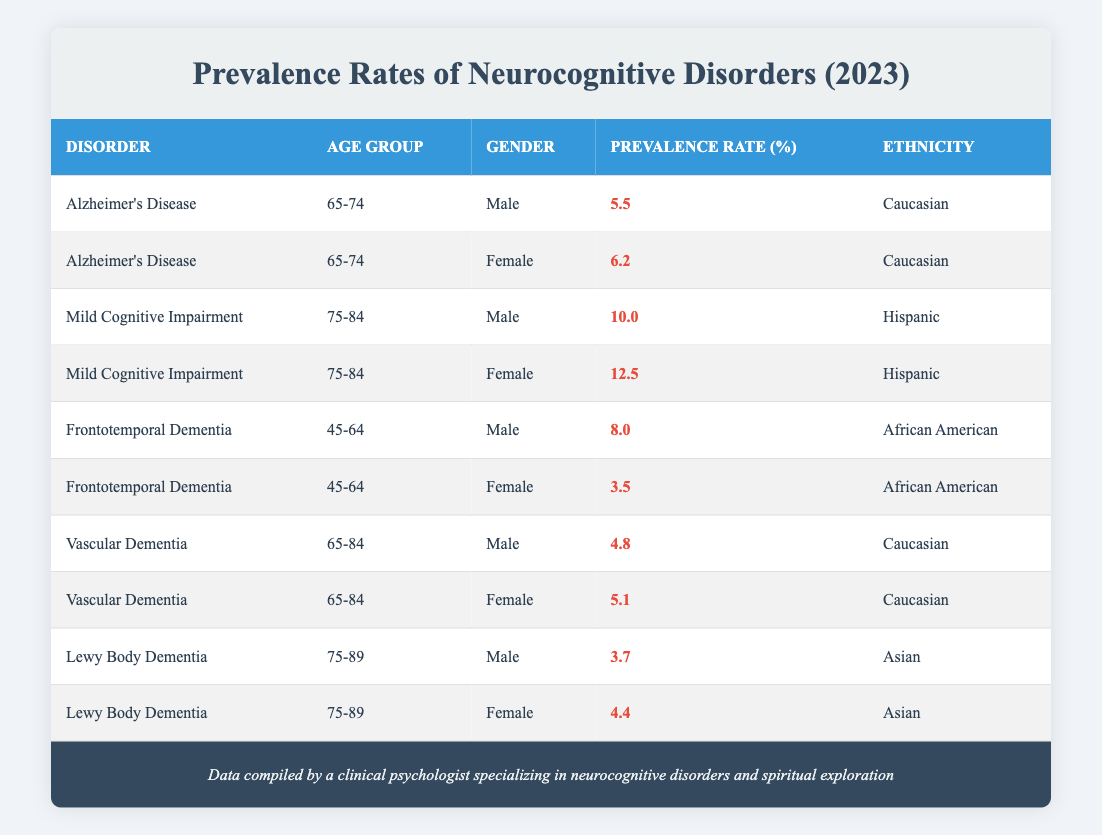What is the prevalence rate of Alzheimer's Disease in females aged 65-74? The table lists Alzheimer's Disease prevalence rates by gender and age group. For females aged 65-74, the prevalence rate is explicitly stated as 6.2%.
Answer: 6.2% What is the highest prevalence rate of Mild Cognitive Impairment reported? In the table, Mild Cognitive Impairment has two entries: males aged 75-84 with a prevalence rate of 10.0% and females aged 75-84 with a prevalence rate of 12.5%. The highest prevalence rate among these is 12.5%.
Answer: 12.5% Is the prevalence rate for Vascular Dementia in males aged 65-84 greater than that of females in the same age group? For males aged 65-84, the prevalence rate is 4.8%, while for females in the same age group, it is 5.1%. Since 4.8% is less than 5.1%, the statement is false.
Answer: No What is the combined prevalence rate for Frontotemporal Dementia across genders in the age group 45-64? For males aged 45-64, the prevalence rate is 8.0% and for females, it is 3.5%. To find the combined prevalence, we sum these values: 8.0 + 3.5 = 11.5%.
Answer: 11.5% Which ethnicity has the highest prevalence rate for Mild Cognitive Impairment, and what is that rate? The table shows Mild Cognitive Impairment prevalence for Hispanics: 10.0% (males 75-84) and 12.5% (females 75-84). Since both rates belong to Hispanics, the highest prevalence for this ethnicity is 12.5%.
Answer: Hispanic, 12.5% What is the difference in prevalence rates of Lewy Body Dementia between males and females aged 75-89? The prevalence rate for males aged 75-89 is 3.7%, and for females, it is 4.4%. To find the difference, we subtract 3.7 from 4.4: 4.4 - 3.7 = 0.7%.
Answer: 0.7% Is there any demographic group with a higher prevalence of Frontotemporal Dementia in males compared to females? According to the table, males aged 45-64 have a prevalence rate of 8.0% while females in the same category have a rate of 3.5%. Therefore, males have a higher prevalence than females.
Answer: Yes What is the average prevalence rate of Vascular Dementia for both genders aged 65-84? For males aged 65-84, the prevalence rate is 4.8% and for females, it is 5.1%. To find the average, we sum these two rates and divide by 2: (4.8 + 5.1) / 2 = 4.95%.
Answer: 4.95% 